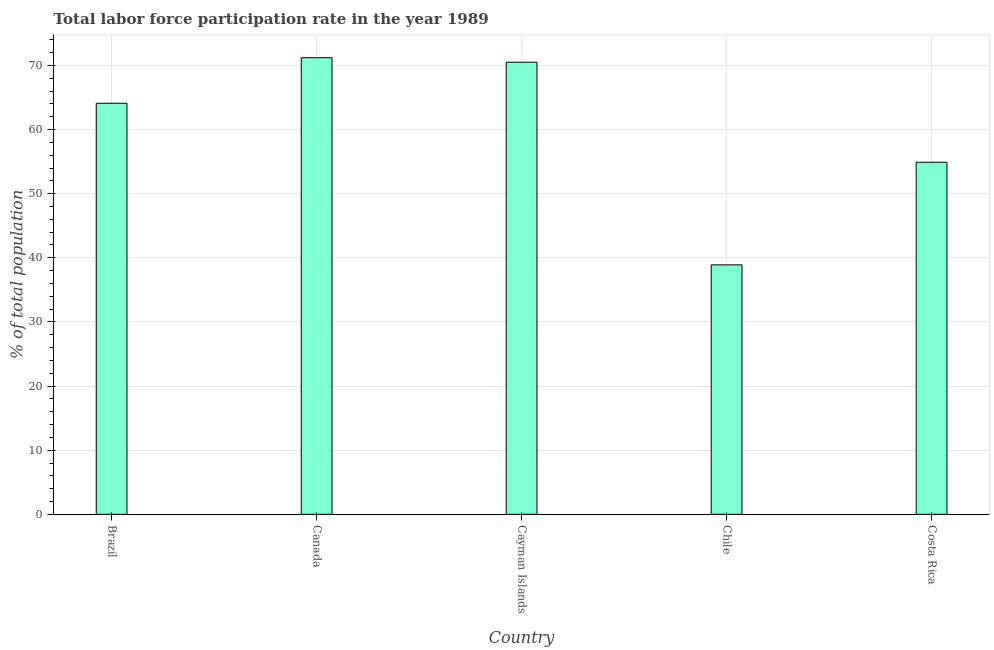Does the graph contain any zero values?
Offer a very short reply. No. Does the graph contain grids?
Provide a succinct answer. Yes. What is the title of the graph?
Offer a terse response. Total labor force participation rate in the year 1989. What is the label or title of the X-axis?
Provide a succinct answer. Country. What is the label or title of the Y-axis?
Ensure brevity in your answer.  % of total population. What is the total labor force participation rate in Canada?
Provide a succinct answer. 71.2. Across all countries, what is the maximum total labor force participation rate?
Your response must be concise. 71.2. Across all countries, what is the minimum total labor force participation rate?
Provide a short and direct response. 38.9. In which country was the total labor force participation rate minimum?
Give a very brief answer. Chile. What is the sum of the total labor force participation rate?
Your answer should be compact. 299.6. What is the difference between the total labor force participation rate in Cayman Islands and Chile?
Offer a terse response. 31.6. What is the average total labor force participation rate per country?
Offer a very short reply. 59.92. What is the median total labor force participation rate?
Your answer should be compact. 64.1. What is the ratio of the total labor force participation rate in Canada to that in Costa Rica?
Provide a short and direct response. 1.3. Is the total labor force participation rate in Brazil less than that in Chile?
Give a very brief answer. No. Is the difference between the total labor force participation rate in Chile and Costa Rica greater than the difference between any two countries?
Keep it short and to the point. No. What is the difference between the highest and the second highest total labor force participation rate?
Provide a short and direct response. 0.7. Is the sum of the total labor force participation rate in Canada and Costa Rica greater than the maximum total labor force participation rate across all countries?
Provide a succinct answer. Yes. What is the difference between the highest and the lowest total labor force participation rate?
Offer a very short reply. 32.3. How many bars are there?
Offer a terse response. 5. Are all the bars in the graph horizontal?
Give a very brief answer. No. What is the difference between two consecutive major ticks on the Y-axis?
Offer a terse response. 10. What is the % of total population of Brazil?
Make the answer very short. 64.1. What is the % of total population in Canada?
Keep it short and to the point. 71.2. What is the % of total population of Cayman Islands?
Provide a succinct answer. 70.5. What is the % of total population in Chile?
Your response must be concise. 38.9. What is the % of total population in Costa Rica?
Make the answer very short. 54.9. What is the difference between the % of total population in Brazil and Chile?
Offer a terse response. 25.2. What is the difference between the % of total population in Brazil and Costa Rica?
Your response must be concise. 9.2. What is the difference between the % of total population in Canada and Chile?
Offer a terse response. 32.3. What is the difference between the % of total population in Cayman Islands and Chile?
Your answer should be compact. 31.6. What is the difference between the % of total population in Chile and Costa Rica?
Offer a terse response. -16. What is the ratio of the % of total population in Brazil to that in Cayman Islands?
Give a very brief answer. 0.91. What is the ratio of the % of total population in Brazil to that in Chile?
Provide a short and direct response. 1.65. What is the ratio of the % of total population in Brazil to that in Costa Rica?
Provide a succinct answer. 1.17. What is the ratio of the % of total population in Canada to that in Chile?
Make the answer very short. 1.83. What is the ratio of the % of total population in Canada to that in Costa Rica?
Ensure brevity in your answer.  1.3. What is the ratio of the % of total population in Cayman Islands to that in Chile?
Ensure brevity in your answer.  1.81. What is the ratio of the % of total population in Cayman Islands to that in Costa Rica?
Offer a very short reply. 1.28. What is the ratio of the % of total population in Chile to that in Costa Rica?
Make the answer very short. 0.71. 